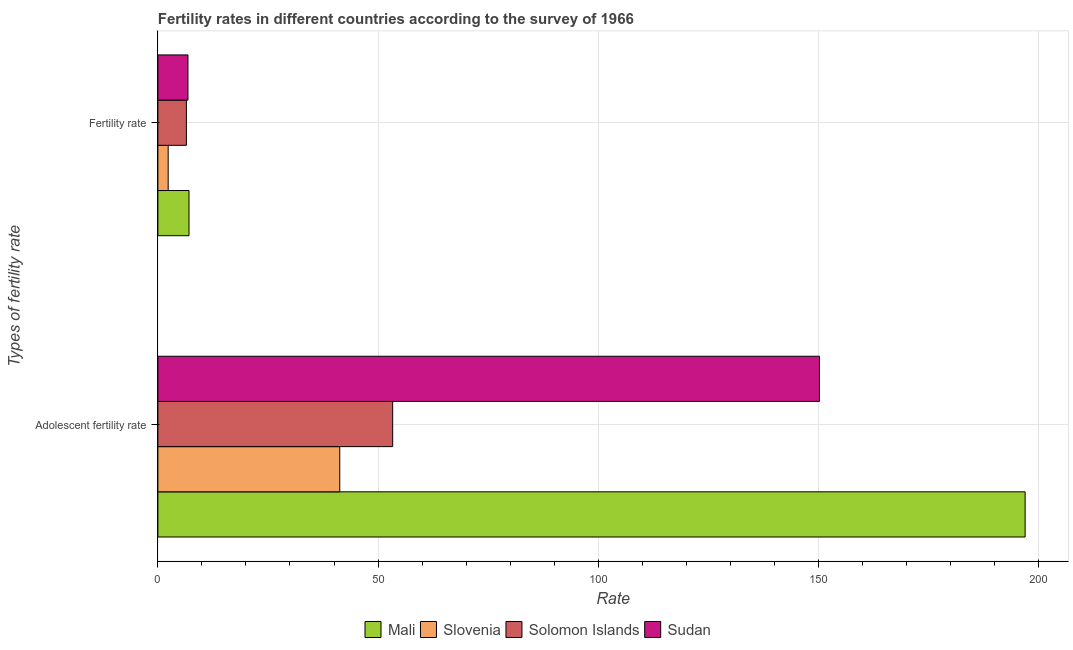How many groups of bars are there?
Your response must be concise. 2. Are the number of bars on each tick of the Y-axis equal?
Provide a short and direct response. Yes. What is the label of the 1st group of bars from the top?
Offer a terse response. Fertility rate. What is the adolescent fertility rate in Mali?
Keep it short and to the point. 196.97. Across all countries, what is the maximum adolescent fertility rate?
Your answer should be compact. 196.97. Across all countries, what is the minimum adolescent fertility rate?
Ensure brevity in your answer.  41.31. In which country was the fertility rate maximum?
Provide a succinct answer. Mali. In which country was the adolescent fertility rate minimum?
Make the answer very short. Slovenia. What is the total adolescent fertility rate in the graph?
Offer a terse response. 441.87. What is the difference between the fertility rate in Sudan and that in Mali?
Offer a very short reply. -0.24. What is the difference between the fertility rate in Slovenia and the adolescent fertility rate in Sudan?
Your response must be concise. -147.93. What is the average adolescent fertility rate per country?
Ensure brevity in your answer.  110.47. What is the difference between the fertility rate and adolescent fertility rate in Sudan?
Your answer should be compact. -143.43. What is the ratio of the adolescent fertility rate in Mali to that in Sudan?
Offer a very short reply. 1.31. What does the 1st bar from the top in Fertility rate represents?
Provide a succinct answer. Sudan. What does the 1st bar from the bottom in Adolescent fertility rate represents?
Your answer should be compact. Mali. Are the values on the major ticks of X-axis written in scientific E-notation?
Your response must be concise. No. Where does the legend appear in the graph?
Provide a short and direct response. Bottom center. How are the legend labels stacked?
Provide a succinct answer. Horizontal. What is the title of the graph?
Keep it short and to the point. Fertility rates in different countries according to the survey of 1966. Does "Myanmar" appear as one of the legend labels in the graph?
Give a very brief answer. No. What is the label or title of the X-axis?
Your answer should be compact. Rate. What is the label or title of the Y-axis?
Your answer should be very brief. Types of fertility rate. What is the Rate of Mali in Adolescent fertility rate?
Keep it short and to the point. 196.97. What is the Rate in Slovenia in Adolescent fertility rate?
Provide a short and direct response. 41.31. What is the Rate in Solomon Islands in Adolescent fertility rate?
Your response must be concise. 53.33. What is the Rate in Sudan in Adolescent fertility rate?
Offer a terse response. 150.26. What is the Rate of Mali in Fertility rate?
Your answer should be very brief. 7.07. What is the Rate in Slovenia in Fertility rate?
Provide a succinct answer. 2.34. What is the Rate of Solomon Islands in Fertility rate?
Your answer should be compact. 6.47. What is the Rate of Sudan in Fertility rate?
Offer a very short reply. 6.83. Across all Types of fertility rate, what is the maximum Rate in Mali?
Give a very brief answer. 196.97. Across all Types of fertility rate, what is the maximum Rate of Slovenia?
Give a very brief answer. 41.31. Across all Types of fertility rate, what is the maximum Rate of Solomon Islands?
Offer a terse response. 53.33. Across all Types of fertility rate, what is the maximum Rate in Sudan?
Keep it short and to the point. 150.26. Across all Types of fertility rate, what is the minimum Rate in Mali?
Your response must be concise. 7.07. Across all Types of fertility rate, what is the minimum Rate in Slovenia?
Your response must be concise. 2.34. Across all Types of fertility rate, what is the minimum Rate in Solomon Islands?
Offer a terse response. 6.47. Across all Types of fertility rate, what is the minimum Rate of Sudan?
Provide a succinct answer. 6.83. What is the total Rate of Mali in the graph?
Provide a short and direct response. 204.04. What is the total Rate of Slovenia in the graph?
Provide a short and direct response. 43.64. What is the total Rate of Solomon Islands in the graph?
Offer a very short reply. 59.8. What is the total Rate in Sudan in the graph?
Offer a terse response. 157.09. What is the difference between the Rate of Mali in Adolescent fertility rate and that in Fertility rate?
Your answer should be very brief. 189.9. What is the difference between the Rate in Slovenia in Adolescent fertility rate and that in Fertility rate?
Give a very brief answer. 38.97. What is the difference between the Rate in Solomon Islands in Adolescent fertility rate and that in Fertility rate?
Keep it short and to the point. 46.86. What is the difference between the Rate of Sudan in Adolescent fertility rate and that in Fertility rate?
Your answer should be very brief. 143.43. What is the difference between the Rate in Mali in Adolescent fertility rate and the Rate in Slovenia in Fertility rate?
Your answer should be very brief. 194.64. What is the difference between the Rate in Mali in Adolescent fertility rate and the Rate in Solomon Islands in Fertility rate?
Provide a succinct answer. 190.5. What is the difference between the Rate of Mali in Adolescent fertility rate and the Rate of Sudan in Fertility rate?
Offer a terse response. 190.14. What is the difference between the Rate in Slovenia in Adolescent fertility rate and the Rate in Solomon Islands in Fertility rate?
Offer a terse response. 34.84. What is the difference between the Rate in Slovenia in Adolescent fertility rate and the Rate in Sudan in Fertility rate?
Your answer should be compact. 34.48. What is the difference between the Rate of Solomon Islands in Adolescent fertility rate and the Rate of Sudan in Fertility rate?
Your answer should be compact. 46.5. What is the average Rate in Mali per Types of fertility rate?
Provide a succinct answer. 102.02. What is the average Rate in Slovenia per Types of fertility rate?
Keep it short and to the point. 21.82. What is the average Rate in Solomon Islands per Types of fertility rate?
Give a very brief answer. 29.9. What is the average Rate of Sudan per Types of fertility rate?
Your response must be concise. 78.55. What is the difference between the Rate in Mali and Rate in Slovenia in Adolescent fertility rate?
Keep it short and to the point. 155.66. What is the difference between the Rate of Mali and Rate of Solomon Islands in Adolescent fertility rate?
Provide a succinct answer. 143.65. What is the difference between the Rate of Mali and Rate of Sudan in Adolescent fertility rate?
Provide a short and direct response. 46.71. What is the difference between the Rate in Slovenia and Rate in Solomon Islands in Adolescent fertility rate?
Offer a terse response. -12.02. What is the difference between the Rate of Slovenia and Rate of Sudan in Adolescent fertility rate?
Give a very brief answer. -108.95. What is the difference between the Rate of Solomon Islands and Rate of Sudan in Adolescent fertility rate?
Your answer should be very brief. -96.94. What is the difference between the Rate in Mali and Rate in Slovenia in Fertility rate?
Make the answer very short. 4.73. What is the difference between the Rate in Mali and Rate in Solomon Islands in Fertility rate?
Your response must be concise. 0.6. What is the difference between the Rate in Mali and Rate in Sudan in Fertility rate?
Offer a terse response. 0.24. What is the difference between the Rate of Slovenia and Rate of Solomon Islands in Fertility rate?
Your answer should be very brief. -4.13. What is the difference between the Rate in Slovenia and Rate in Sudan in Fertility rate?
Provide a succinct answer. -4.5. What is the difference between the Rate in Solomon Islands and Rate in Sudan in Fertility rate?
Give a very brief answer. -0.36. What is the ratio of the Rate in Mali in Adolescent fertility rate to that in Fertility rate?
Your answer should be compact. 27.86. What is the ratio of the Rate in Slovenia in Adolescent fertility rate to that in Fertility rate?
Make the answer very short. 17.68. What is the ratio of the Rate in Solomon Islands in Adolescent fertility rate to that in Fertility rate?
Keep it short and to the point. 8.24. What is the ratio of the Rate in Sudan in Adolescent fertility rate to that in Fertility rate?
Give a very brief answer. 22. What is the difference between the highest and the second highest Rate in Mali?
Your answer should be compact. 189.9. What is the difference between the highest and the second highest Rate in Slovenia?
Offer a very short reply. 38.97. What is the difference between the highest and the second highest Rate in Solomon Islands?
Provide a succinct answer. 46.86. What is the difference between the highest and the second highest Rate of Sudan?
Provide a succinct answer. 143.43. What is the difference between the highest and the lowest Rate of Mali?
Offer a very short reply. 189.9. What is the difference between the highest and the lowest Rate in Slovenia?
Your response must be concise. 38.97. What is the difference between the highest and the lowest Rate in Solomon Islands?
Keep it short and to the point. 46.86. What is the difference between the highest and the lowest Rate in Sudan?
Your response must be concise. 143.43. 